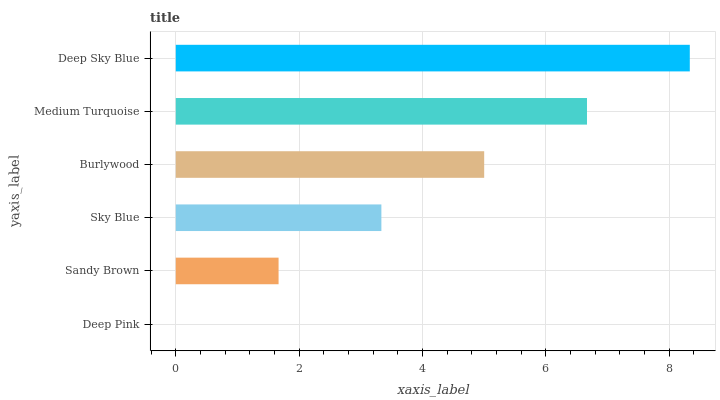Is Deep Pink the minimum?
Answer yes or no. Yes. Is Deep Sky Blue the maximum?
Answer yes or no. Yes. Is Sandy Brown the minimum?
Answer yes or no. No. Is Sandy Brown the maximum?
Answer yes or no. No. Is Sandy Brown greater than Deep Pink?
Answer yes or no. Yes. Is Deep Pink less than Sandy Brown?
Answer yes or no. Yes. Is Deep Pink greater than Sandy Brown?
Answer yes or no. No. Is Sandy Brown less than Deep Pink?
Answer yes or no. No. Is Burlywood the high median?
Answer yes or no. Yes. Is Sky Blue the low median?
Answer yes or no. Yes. Is Sandy Brown the high median?
Answer yes or no. No. Is Medium Turquoise the low median?
Answer yes or no. No. 